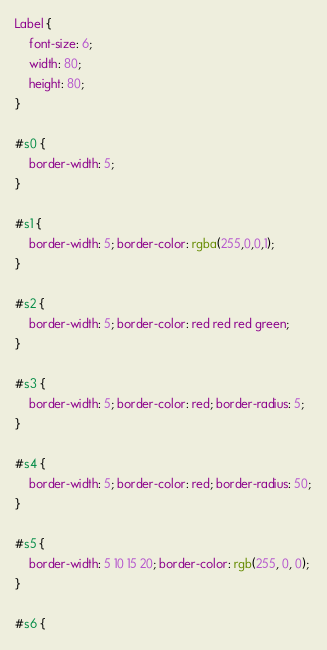<code> <loc_0><loc_0><loc_500><loc_500><_CSS_>Label {
    font-size: 6;
    width: 80;
    height: 80;
}

#s0 {
    border-width: 5;
}

#s1 {
    border-width: 5; border-color: rgba(255,0,0,1);
}

#s2 {
    border-width: 5; border-color: red red red green;
}

#s3 {
    border-width: 5; border-color: red; border-radius: 5;
}

#s4 {
    border-width: 5; border-color: red; border-radius: 50;
}

#s5 {
    border-width: 5 10 15 20; border-color: rgb(255, 0, 0); 
}

#s6 {</code> 